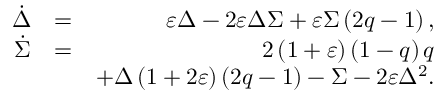Convert formula to latex. <formula><loc_0><loc_0><loc_500><loc_500>\begin{array} { r l r } { \dot { \Delta } } & { = } & { \varepsilon \Delta - 2 \varepsilon \Delta \Sigma + \varepsilon \Sigma \left ( 2 q - 1 \right ) , } \\ { \dot { \Sigma } } & { = } & { 2 \left ( 1 + \varepsilon \right ) \left ( 1 - q \right ) q } \\ & { + \Delta \left ( 1 + 2 \varepsilon \right ) \left ( 2 q - 1 \right ) - \Sigma - 2 \varepsilon \Delta ^ { 2 } . } \end{array}</formula> 